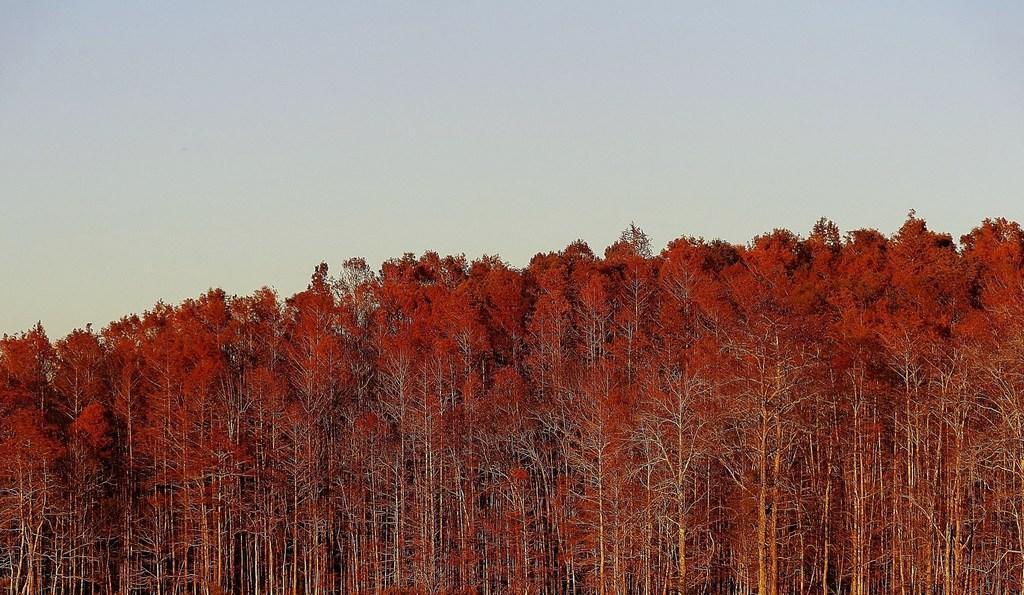Could you give a brief overview of what you see in this image? At the bottom of the picture, we see trees which are red in color. At the top of the picture, we see the sky. 